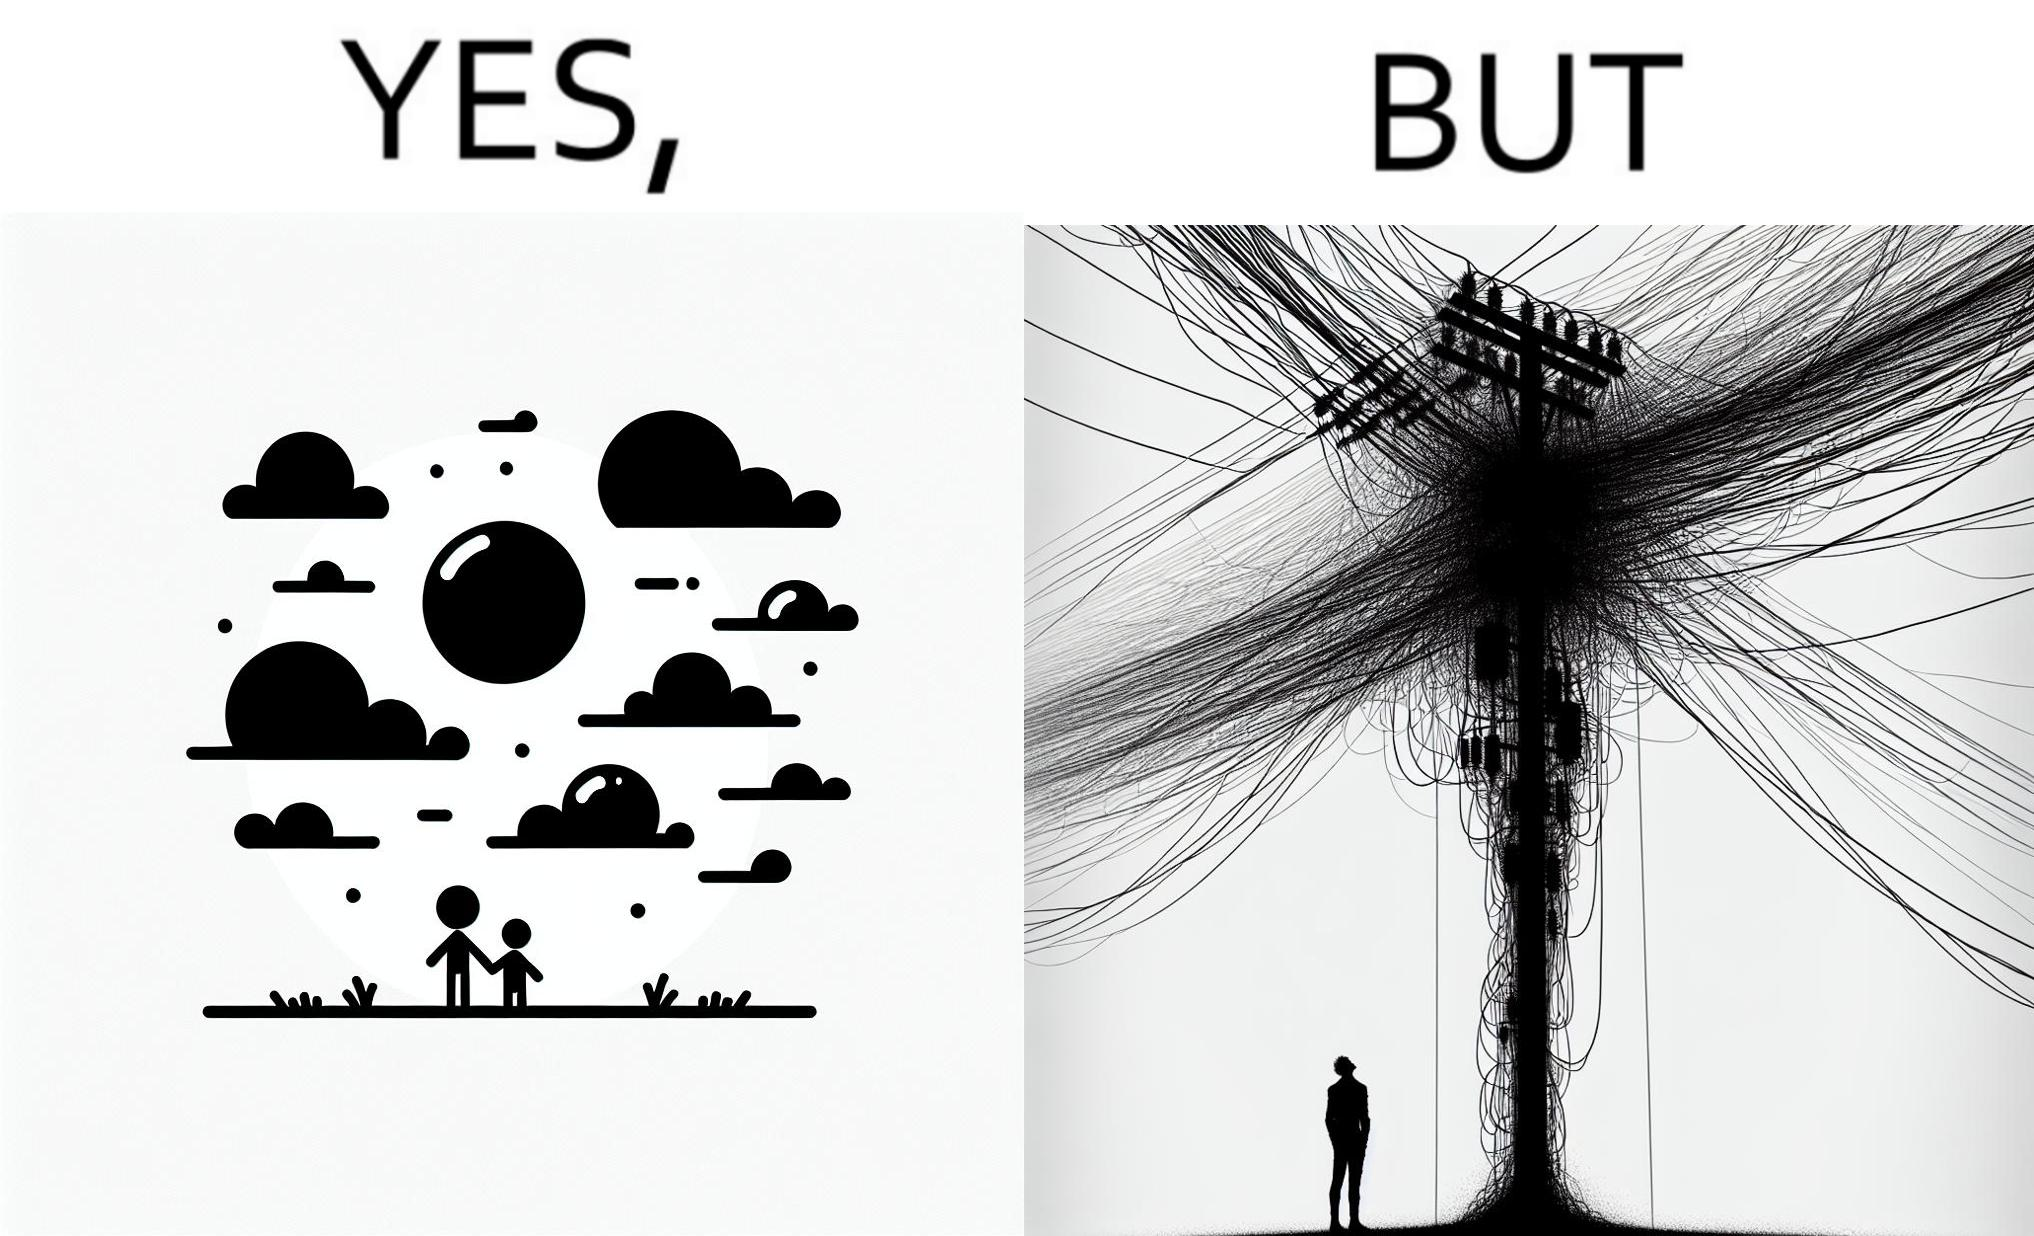Is this image satirical or non-satirical? Yes, this image is satirical. 